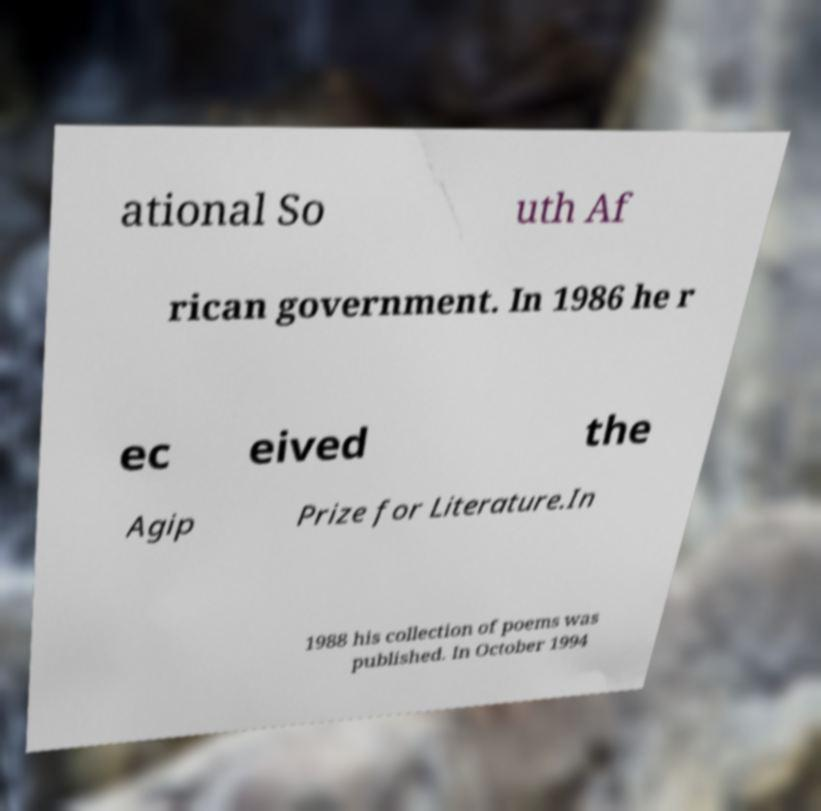There's text embedded in this image that I need extracted. Can you transcribe it verbatim? ational So uth Af rican government. In 1986 he r ec eived the Agip Prize for Literature.In 1988 his collection of poems was published. In October 1994 